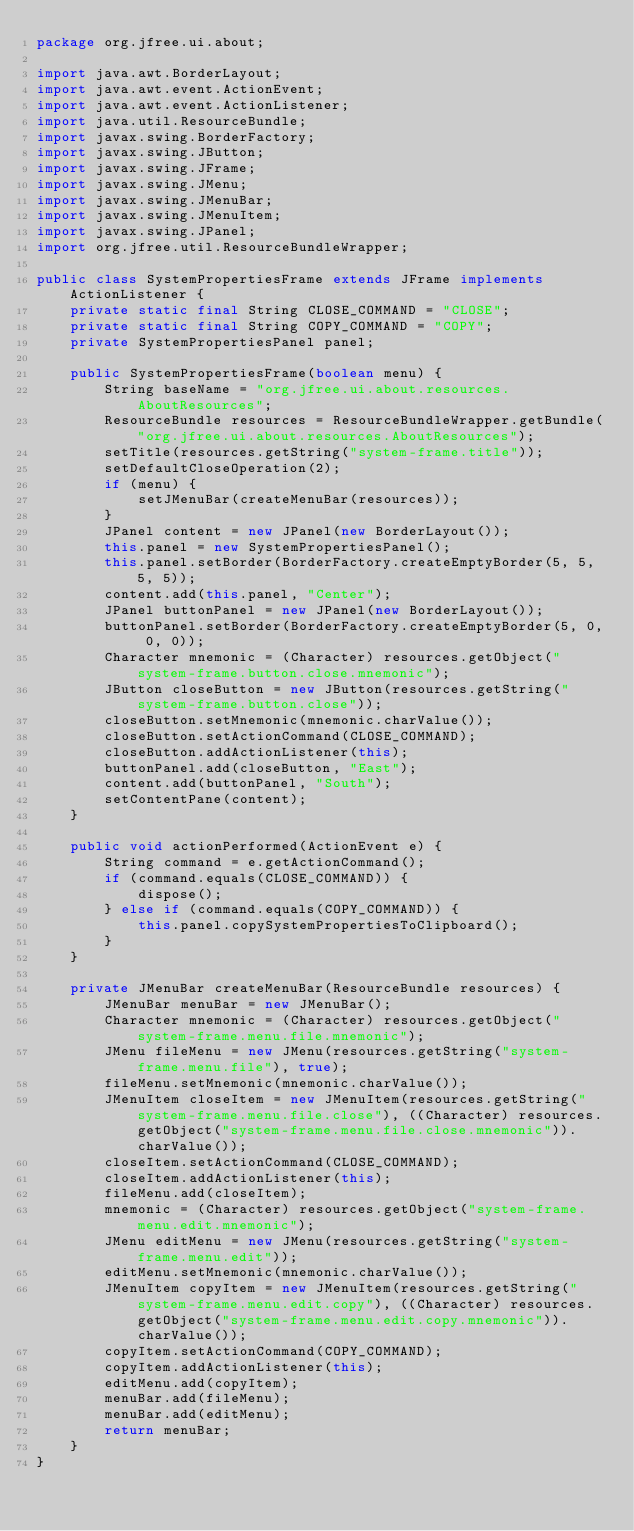Convert code to text. <code><loc_0><loc_0><loc_500><loc_500><_Java_>package org.jfree.ui.about;

import java.awt.BorderLayout;
import java.awt.event.ActionEvent;
import java.awt.event.ActionListener;
import java.util.ResourceBundle;
import javax.swing.BorderFactory;
import javax.swing.JButton;
import javax.swing.JFrame;
import javax.swing.JMenu;
import javax.swing.JMenuBar;
import javax.swing.JMenuItem;
import javax.swing.JPanel;
import org.jfree.util.ResourceBundleWrapper;

public class SystemPropertiesFrame extends JFrame implements ActionListener {
    private static final String CLOSE_COMMAND = "CLOSE";
    private static final String COPY_COMMAND = "COPY";
    private SystemPropertiesPanel panel;

    public SystemPropertiesFrame(boolean menu) {
        String baseName = "org.jfree.ui.about.resources.AboutResources";
        ResourceBundle resources = ResourceBundleWrapper.getBundle("org.jfree.ui.about.resources.AboutResources");
        setTitle(resources.getString("system-frame.title"));
        setDefaultCloseOperation(2);
        if (menu) {
            setJMenuBar(createMenuBar(resources));
        }
        JPanel content = new JPanel(new BorderLayout());
        this.panel = new SystemPropertiesPanel();
        this.panel.setBorder(BorderFactory.createEmptyBorder(5, 5, 5, 5));
        content.add(this.panel, "Center");
        JPanel buttonPanel = new JPanel(new BorderLayout());
        buttonPanel.setBorder(BorderFactory.createEmptyBorder(5, 0, 0, 0));
        Character mnemonic = (Character) resources.getObject("system-frame.button.close.mnemonic");
        JButton closeButton = new JButton(resources.getString("system-frame.button.close"));
        closeButton.setMnemonic(mnemonic.charValue());
        closeButton.setActionCommand(CLOSE_COMMAND);
        closeButton.addActionListener(this);
        buttonPanel.add(closeButton, "East");
        content.add(buttonPanel, "South");
        setContentPane(content);
    }

    public void actionPerformed(ActionEvent e) {
        String command = e.getActionCommand();
        if (command.equals(CLOSE_COMMAND)) {
            dispose();
        } else if (command.equals(COPY_COMMAND)) {
            this.panel.copySystemPropertiesToClipboard();
        }
    }

    private JMenuBar createMenuBar(ResourceBundle resources) {
        JMenuBar menuBar = new JMenuBar();
        Character mnemonic = (Character) resources.getObject("system-frame.menu.file.mnemonic");
        JMenu fileMenu = new JMenu(resources.getString("system-frame.menu.file"), true);
        fileMenu.setMnemonic(mnemonic.charValue());
        JMenuItem closeItem = new JMenuItem(resources.getString("system-frame.menu.file.close"), ((Character) resources.getObject("system-frame.menu.file.close.mnemonic")).charValue());
        closeItem.setActionCommand(CLOSE_COMMAND);
        closeItem.addActionListener(this);
        fileMenu.add(closeItem);
        mnemonic = (Character) resources.getObject("system-frame.menu.edit.mnemonic");
        JMenu editMenu = new JMenu(resources.getString("system-frame.menu.edit"));
        editMenu.setMnemonic(mnemonic.charValue());
        JMenuItem copyItem = new JMenuItem(resources.getString("system-frame.menu.edit.copy"), ((Character) resources.getObject("system-frame.menu.edit.copy.mnemonic")).charValue());
        copyItem.setActionCommand(COPY_COMMAND);
        copyItem.addActionListener(this);
        editMenu.add(copyItem);
        menuBar.add(fileMenu);
        menuBar.add(editMenu);
        return menuBar;
    }
}
</code> 